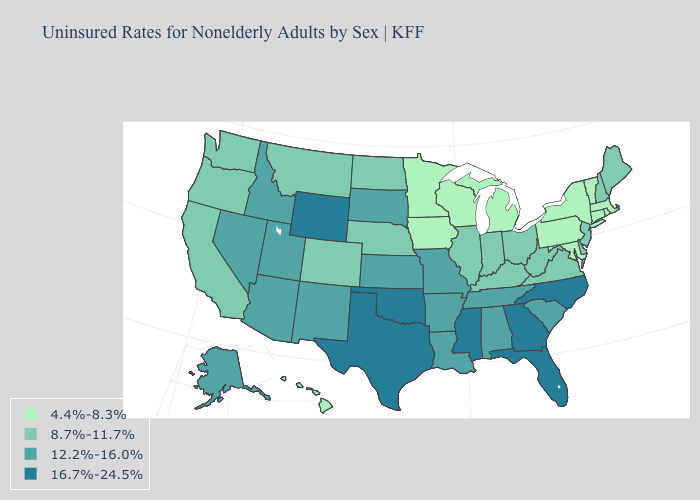Does the first symbol in the legend represent the smallest category?
Concise answer only. Yes. Name the states that have a value in the range 8.7%-11.7%?
Be succinct. California, Colorado, Delaware, Illinois, Indiana, Kentucky, Maine, Montana, Nebraska, New Hampshire, New Jersey, North Dakota, Ohio, Oregon, Virginia, Washington, West Virginia. Does Iowa have the same value as Alabama?
Write a very short answer. No. Name the states that have a value in the range 4.4%-8.3%?
Concise answer only. Connecticut, Hawaii, Iowa, Maryland, Massachusetts, Michigan, Minnesota, New York, Pennsylvania, Rhode Island, Vermont, Wisconsin. What is the value of Wyoming?
Concise answer only. 16.7%-24.5%. Which states have the highest value in the USA?
Answer briefly. Florida, Georgia, Mississippi, North Carolina, Oklahoma, Texas, Wyoming. What is the highest value in the USA?
Concise answer only. 16.7%-24.5%. What is the lowest value in the USA?
Short answer required. 4.4%-8.3%. Among the states that border Massachusetts , does New Hampshire have the highest value?
Answer briefly. Yes. Name the states that have a value in the range 8.7%-11.7%?
Concise answer only. California, Colorado, Delaware, Illinois, Indiana, Kentucky, Maine, Montana, Nebraska, New Hampshire, New Jersey, North Dakota, Ohio, Oregon, Virginia, Washington, West Virginia. Name the states that have a value in the range 8.7%-11.7%?
Keep it brief. California, Colorado, Delaware, Illinois, Indiana, Kentucky, Maine, Montana, Nebraska, New Hampshire, New Jersey, North Dakota, Ohio, Oregon, Virginia, Washington, West Virginia. What is the value of New York?
Write a very short answer. 4.4%-8.3%. Does the first symbol in the legend represent the smallest category?
Concise answer only. Yes. Is the legend a continuous bar?
Write a very short answer. No. Name the states that have a value in the range 4.4%-8.3%?
Answer briefly. Connecticut, Hawaii, Iowa, Maryland, Massachusetts, Michigan, Minnesota, New York, Pennsylvania, Rhode Island, Vermont, Wisconsin. 